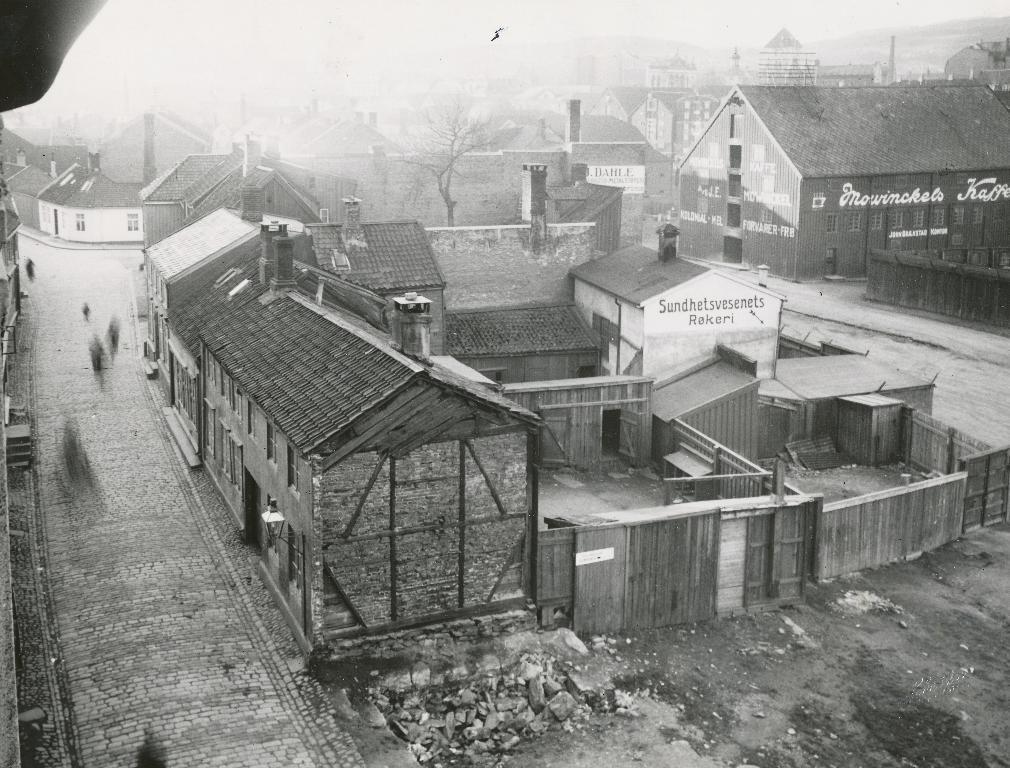What is the color scheme of the image? The image is black and white. What type of structures can be seen in the image? There are houses in the image. What other objects are present in the image? There are boards and trees in the image. What type of engine can be seen in the image? There is no engine present in the image. Is there a pipe visible in the image? There is no pipe visible in the image. 